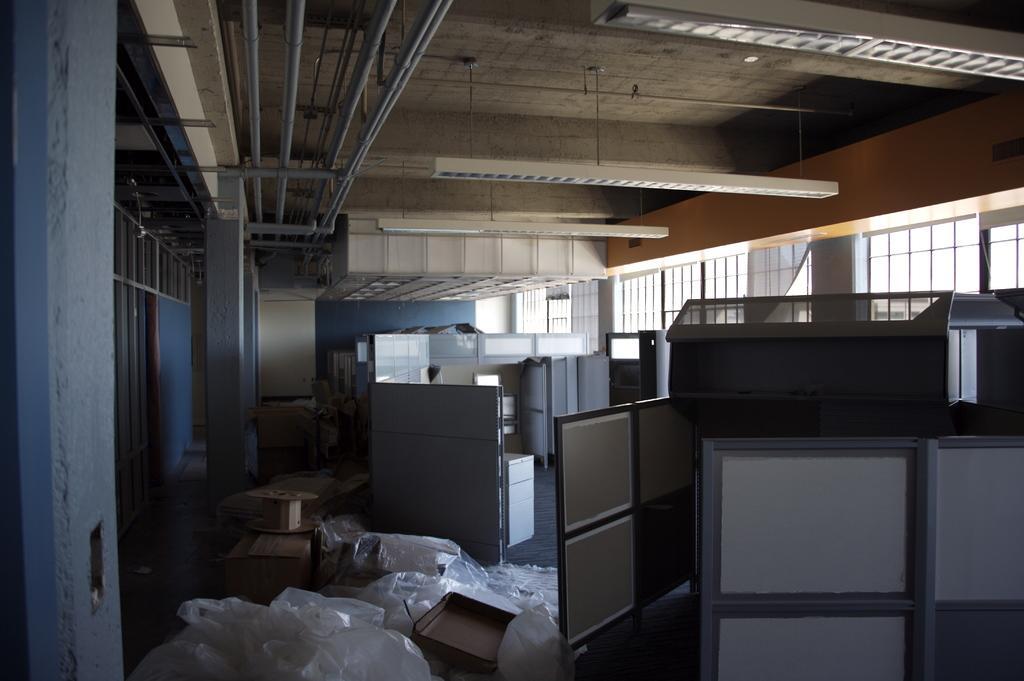Can you describe this image briefly? This image is taken indoors. At the bottom of the image there are many plastic covers and a few cardboard boxes on the floor. In the background there is a wall and there are a few windows. At the top of the image there is a ceiling with a few lights and there are a few iron bars and grills. In the middle of the image there are a few cupboards and shelves. 